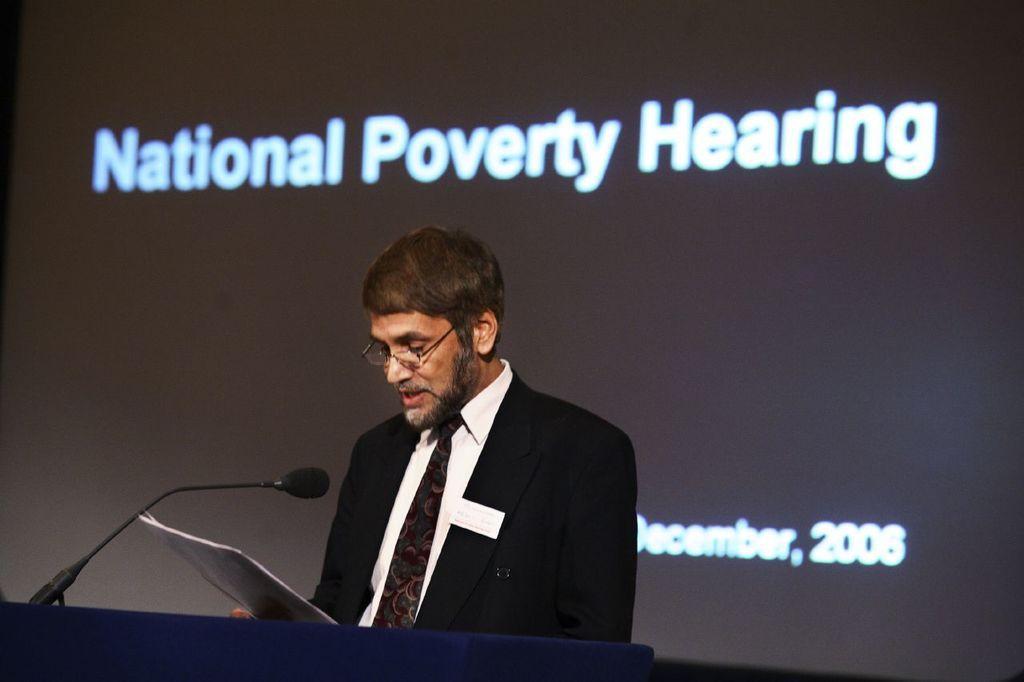Please provide a concise description of this image. In the center of the image we can see person standing and holding paper and standing at the desk. On the desk we can see mic. In the background there is screen. 